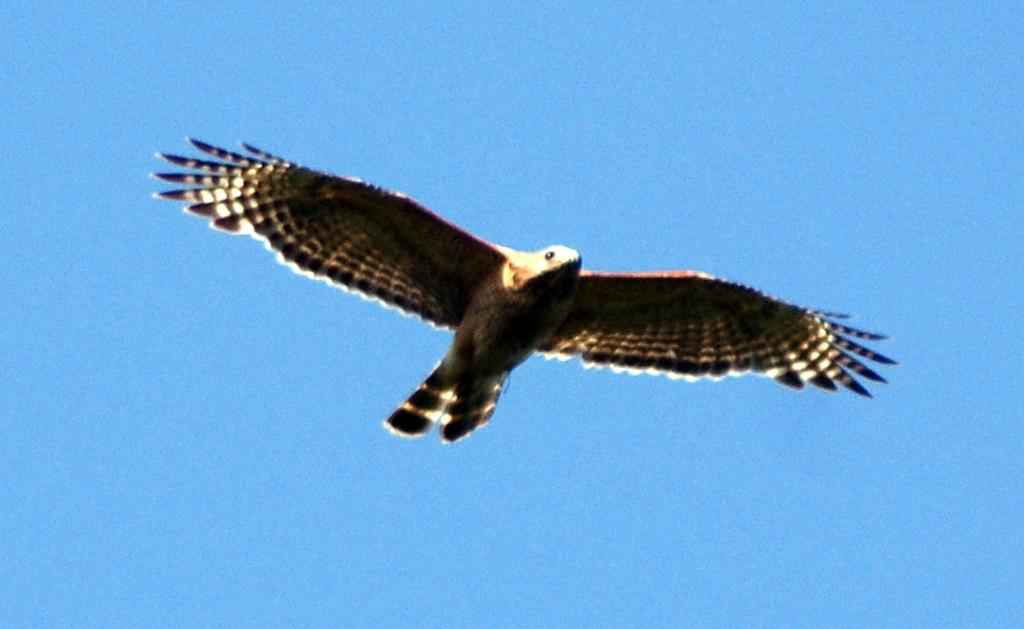What animal is featured in the picture? There is an eagle in the picture. What is the eagle doing in the image? The eagle is flying in the air. What is the color of the eagle? The eagle is black in color. Are there any distinctive markings on the eagle's wings? Yes, the eagle's wings have white lines. What color is the sky in the background of the image? The sky in the background is blue in color. What type of paper is the eagle using to write its answers in the image? There is no paper present in the image, and eagles do not have the ability to write. 